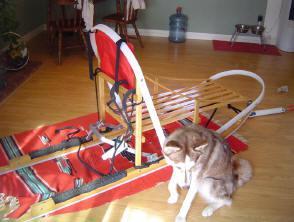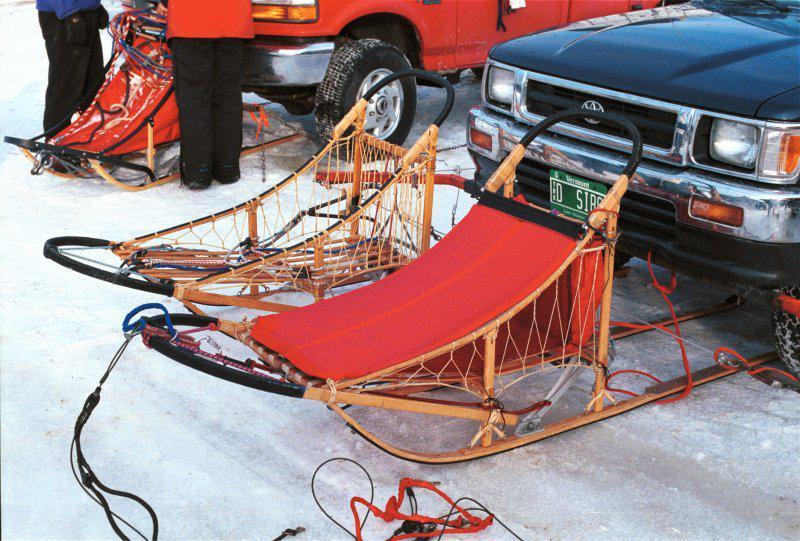The first image is the image on the left, the second image is the image on the right. Examine the images to the left and right. Is the description "In the image on the left there is one dog." accurate? Answer yes or no. Yes. The first image is the image on the left, the second image is the image on the right. Examine the images to the left and right. Is the description "The left image shows a dog in front of a riderless sled featuring red on it, and the right image shows a row of empty sleds." accurate? Answer yes or no. Yes. 